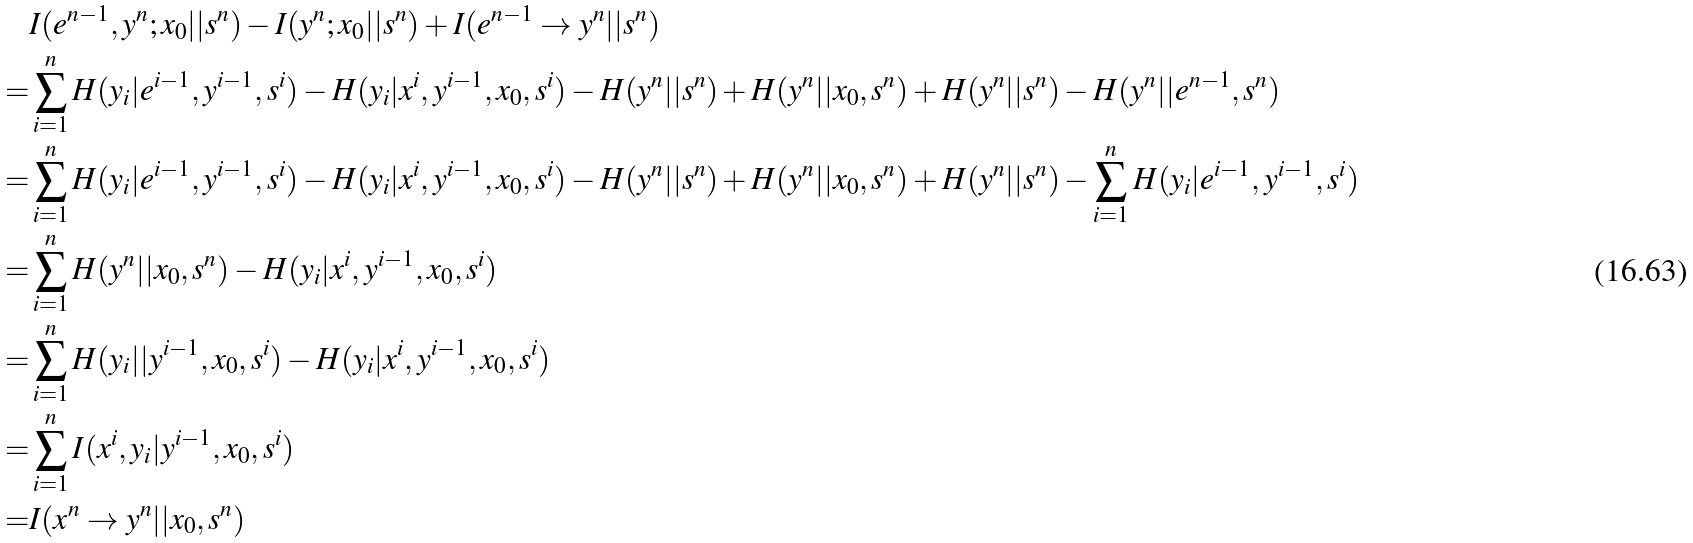Convert formula to latex. <formula><loc_0><loc_0><loc_500><loc_500>& I ( e ^ { n - 1 } , y ^ { n } ; x _ { 0 } | | s ^ { n } ) - I ( y ^ { n } ; x _ { 0 } | | s ^ { n } ) + I ( e ^ { n - 1 } \rightarrow y ^ { n } | | s ^ { n } ) \\ = & \sum _ { i = 1 } ^ { n } H ( y _ { i } | e ^ { i - 1 } , y ^ { i - 1 } , s ^ { i } ) - H ( y _ { i } | x ^ { i } , y ^ { i - 1 } , x _ { 0 } , s ^ { i } ) - H ( y ^ { n } | | s ^ { n } ) + H ( y ^ { n } | | x _ { 0 } , s ^ { n } ) + H ( y ^ { n } | | s ^ { n } ) - H ( y ^ { n } | | e ^ { n - 1 } , s ^ { n } ) \\ = & \sum _ { i = 1 } ^ { n } H ( y _ { i } | e ^ { i - 1 } , y ^ { i - 1 } , s ^ { i } ) - H ( y _ { i } | x ^ { i } , y ^ { i - 1 } , x _ { 0 } , s ^ { i } ) - H ( y ^ { n } | | s ^ { n } ) + H ( y ^ { n } | | x _ { 0 } , s ^ { n } ) + H ( y ^ { n } | | s ^ { n } ) - \sum _ { i = 1 } ^ { n } H ( y _ { i } | e ^ { i - 1 } , y ^ { i - 1 } , s ^ { i } ) \\ = & \sum _ { i = 1 } ^ { n } H ( y ^ { n } | | x _ { 0 } , s ^ { n } ) - H ( y _ { i } | x ^ { i } , y ^ { i - 1 } , x _ { 0 } , s ^ { i } ) \\ = & \sum _ { i = 1 } ^ { n } H ( y _ { i } | | y ^ { i - 1 } , x _ { 0 } , s ^ { i } ) - H ( y _ { i } | x ^ { i } , y ^ { i - 1 } , x _ { 0 } , s ^ { i } ) \\ = & \sum _ { i = 1 } ^ { n } I ( x ^ { i } , y _ { i } | y ^ { i - 1 } , x _ { 0 } , s ^ { i } ) \\ = & I ( x ^ { n } \rightarrow y ^ { n } | | x _ { 0 } , s ^ { n } ) \\</formula> 